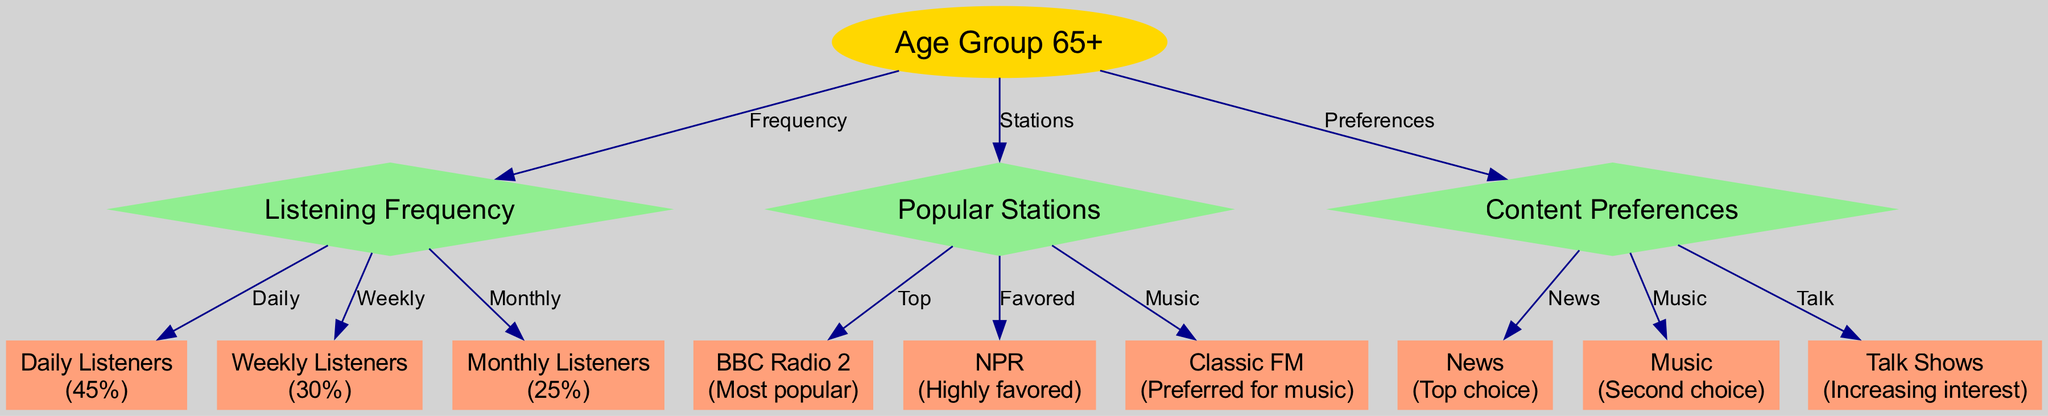What percentage of listeners aged 65 and above listen daily? From the "Listening Frequency" category, we can see the "Daily Listeners" node which indicates "45%". This directly answers the question regarding the daily listeners.
Answer: 45% Which station is the most popular among listeners aged 65 and above? By looking at the "Popular Stations" category, the node "BBC Radio 2" states it is the "Most popular", confirming its status among this demographic.
Answer: BBC Radio 2 What type of content is the top choice for radio listeners aged 65 and above? In the "Content Preferences" category, the node "News" is labeled as the "Top choice", indicating that this is the preferred content type for these listeners.
Answer: News How many edges are connecting the "Age Group 65+" node in the diagram? The "Age Group 65+" has three connections: one to "Listening Frequency", one to "Popular Stations", and one to "Content Preferences", resulting in a total of three edges.
Answer: 3 Which station is highly favored by listeners aged 65 and above? From the "Popular Stations" section, we see that the node "NPR" mentions being "Highly favored", which directly answers the inquiry about listener preferences.
Answer: NPR What percentage of listeners aged 65 and above listen monthly? Referring to the "Listening Frequency" category, the "Monthly Listeners" node shows "25%". This is the specific figure related to monthly listenership for this demographic.
Answer: 25% What content preference shows increasing interest among elderly listeners? In the "Content Preferences" category, the node "Talk Shows" indicates "Increasing interest", which suggests a growing trend among this age group for this type of content.
Answer: Talk Shows How many total nodes are present in the diagram? Counting all the nodes listed, including the main node, categories, and data nodes, we arrive at a total of thirteen nodes.
Answer: 13 What is the value indicating weekly listeners aged 65 and above? The "Weekly Listeners" node in the "Listening Frequency" category clearly states "30%", which represents the percentage of this demographic who listen weekly.
Answer: 30% 